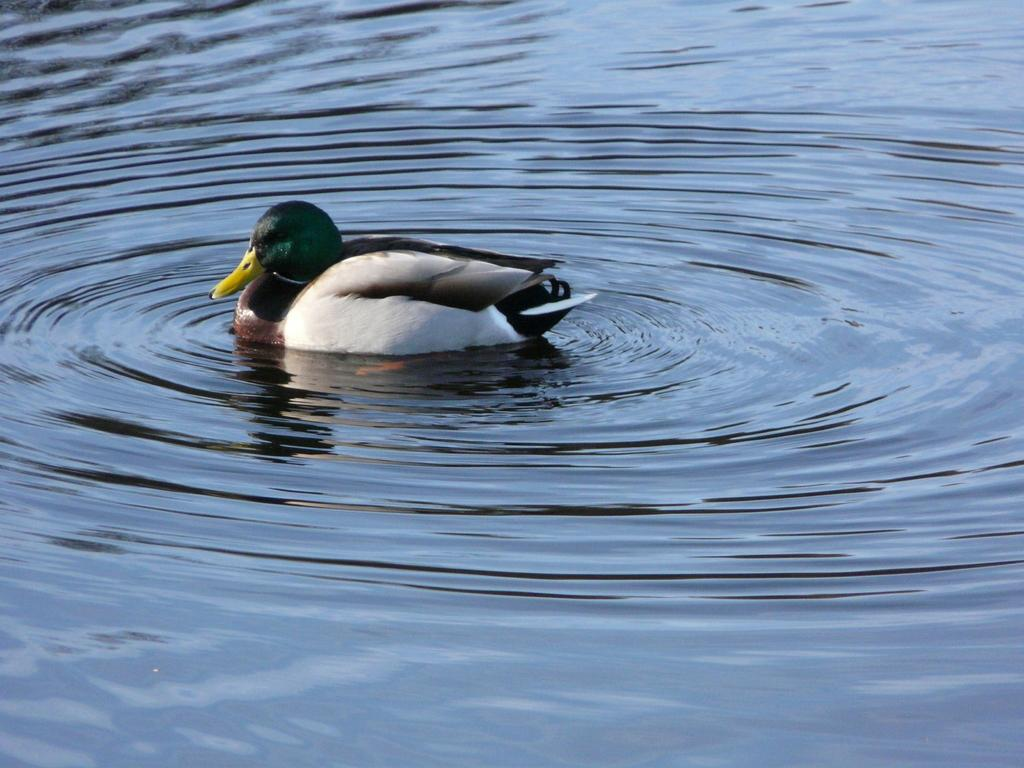What type of animal is present in the image? There is a duck in the image. What is the duck doing in the image? The duck is swimming in the water. What type of writing can be seen on the duck's back in the image? There is no writing visible on the duck's back in the image. How does the duck show self-care in the image? The concept of self-care does not apply to the duck in the image, as it is an animal and not capable of understanding or practicing self-care. 